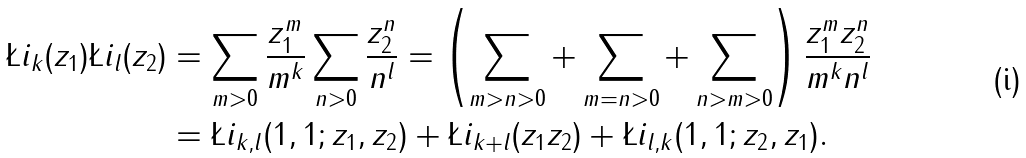Convert formula to latex. <formula><loc_0><loc_0><loc_500><loc_500>\L i _ { k } ( z _ { 1 } ) \L i _ { l } ( z _ { 2 } ) & = \sum _ { m > 0 } \frac { z _ { 1 } ^ { m } } { m ^ { k } } \sum _ { n > 0 } \frac { z _ { 2 } ^ { n } } { n ^ { l } } = \left ( \sum _ { m > n > 0 } + \sum _ { m = n > 0 } + \sum _ { n > m > 0 } \right ) \frac { z _ { 1 } ^ { m } z _ { 2 } ^ { n } } { m ^ { k } n ^ { l } } \\ & = \L i _ { k , l } ( 1 , 1 ; z _ { 1 } , z _ { 2 } ) + \L i _ { k + l } ( z _ { 1 } z _ { 2 } ) + \L i _ { l , k } ( 1 , 1 ; z _ { 2 } , z _ { 1 } ) .</formula> 